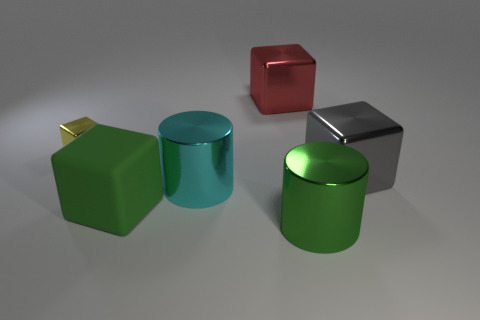Subtract all big red metal cubes. How many cubes are left? 3 Subtract all red cubes. How many cubes are left? 3 Add 1 cyan cylinders. How many objects exist? 7 Subtract 2 blocks. How many blocks are left? 2 Subtract all cyan blocks. Subtract all blue spheres. How many blocks are left? 4 Subtract all red cubes. Subtract all brown matte balls. How many objects are left? 5 Add 5 tiny yellow shiny cubes. How many tiny yellow shiny cubes are left? 6 Add 5 large red things. How many large red things exist? 6 Subtract 1 red cubes. How many objects are left? 5 Subtract all cubes. How many objects are left? 2 